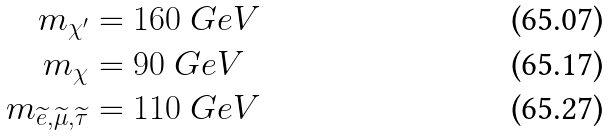<formula> <loc_0><loc_0><loc_500><loc_500>m _ { \chi ^ { \prime } } & = 1 6 0 \ G e V \\ m _ { \chi } & = 9 0 \ G e V \\ m _ { \widetilde { e } , \widetilde { \mu } , \widetilde { \tau } } & = 1 1 0 \ G e V</formula> 